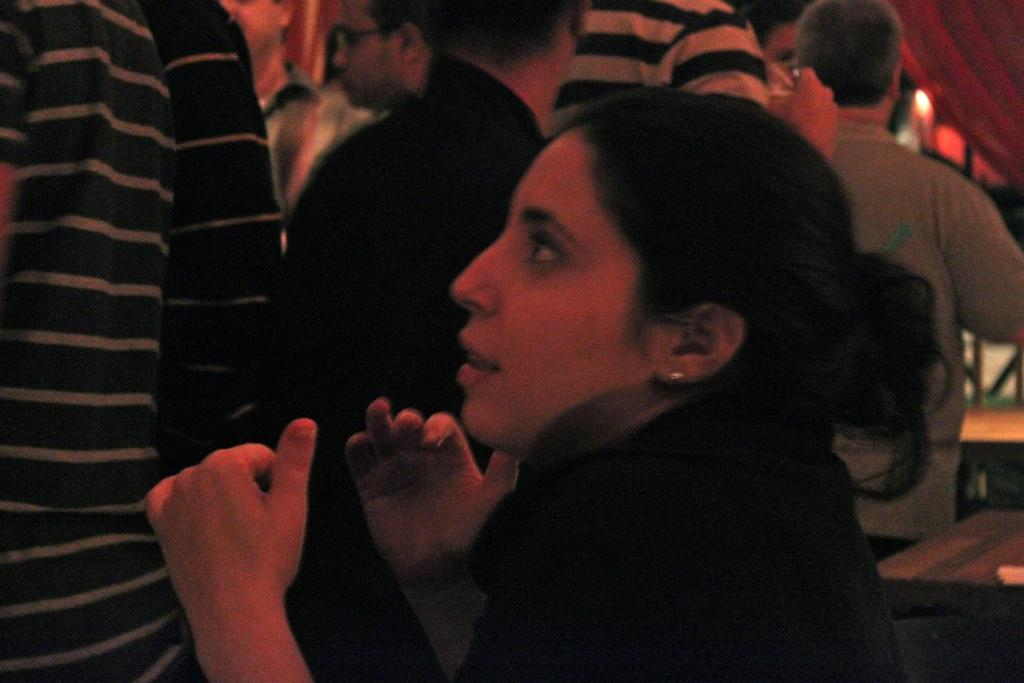What can be seen in the background of the image? There are people in the background of the image. Can you describe the woman in the image? There is a woman in the image. What is located on the right side of the image? There are objects on the right side of the image. Can you identify any light source in the image? A light is visible in the image. What type of pen is being used by the woman in the image? There is no pen present in the image. How does the drain affect the lighting in the image? There is no drain present in the image, so it cannot affect the lighting. 